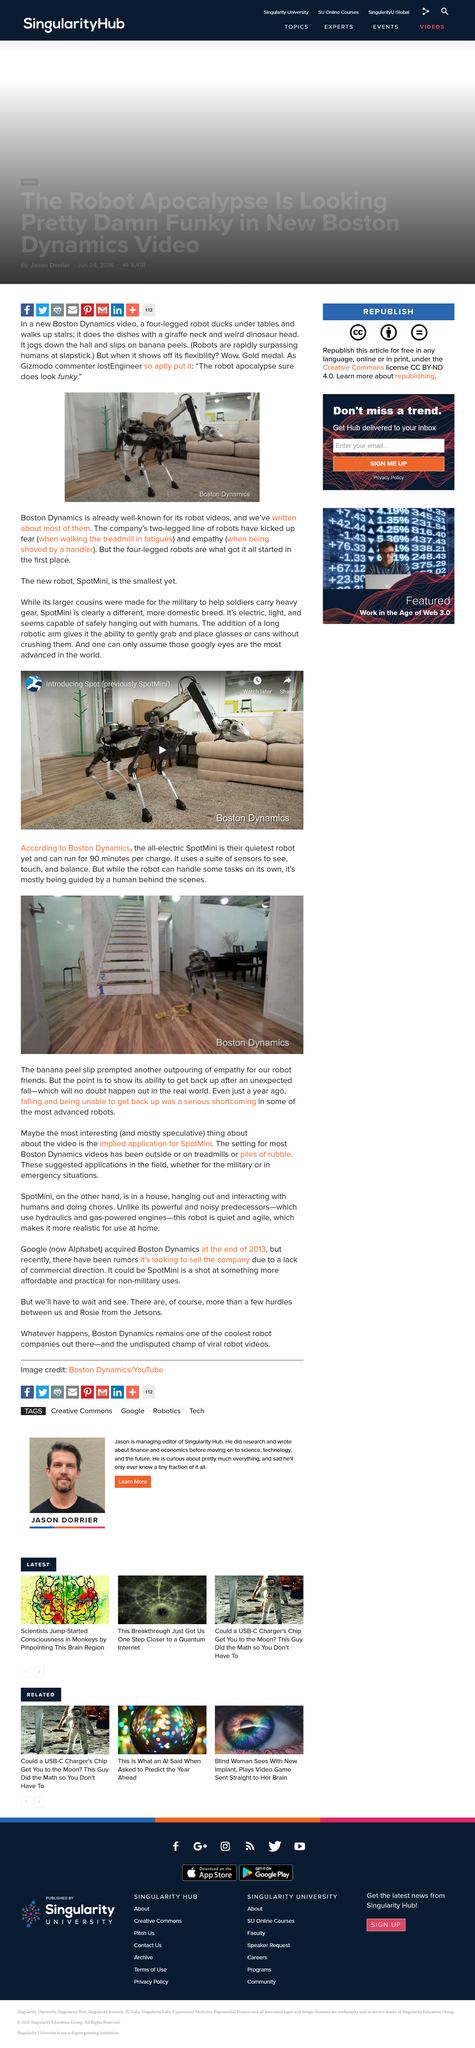Outline some significant characteristics in this image. The SpotMini's quiet and agile nature provides numerous benefits, making it an ideal choice for use at home. The SpotMini can run for up to 90 minutes on a single charge. Yes, it can also hang with humans. The source of the image is Boston Dynamics. The robot in the new Boston Dynamics video has four legs, and therefore it has a total of four legs. 